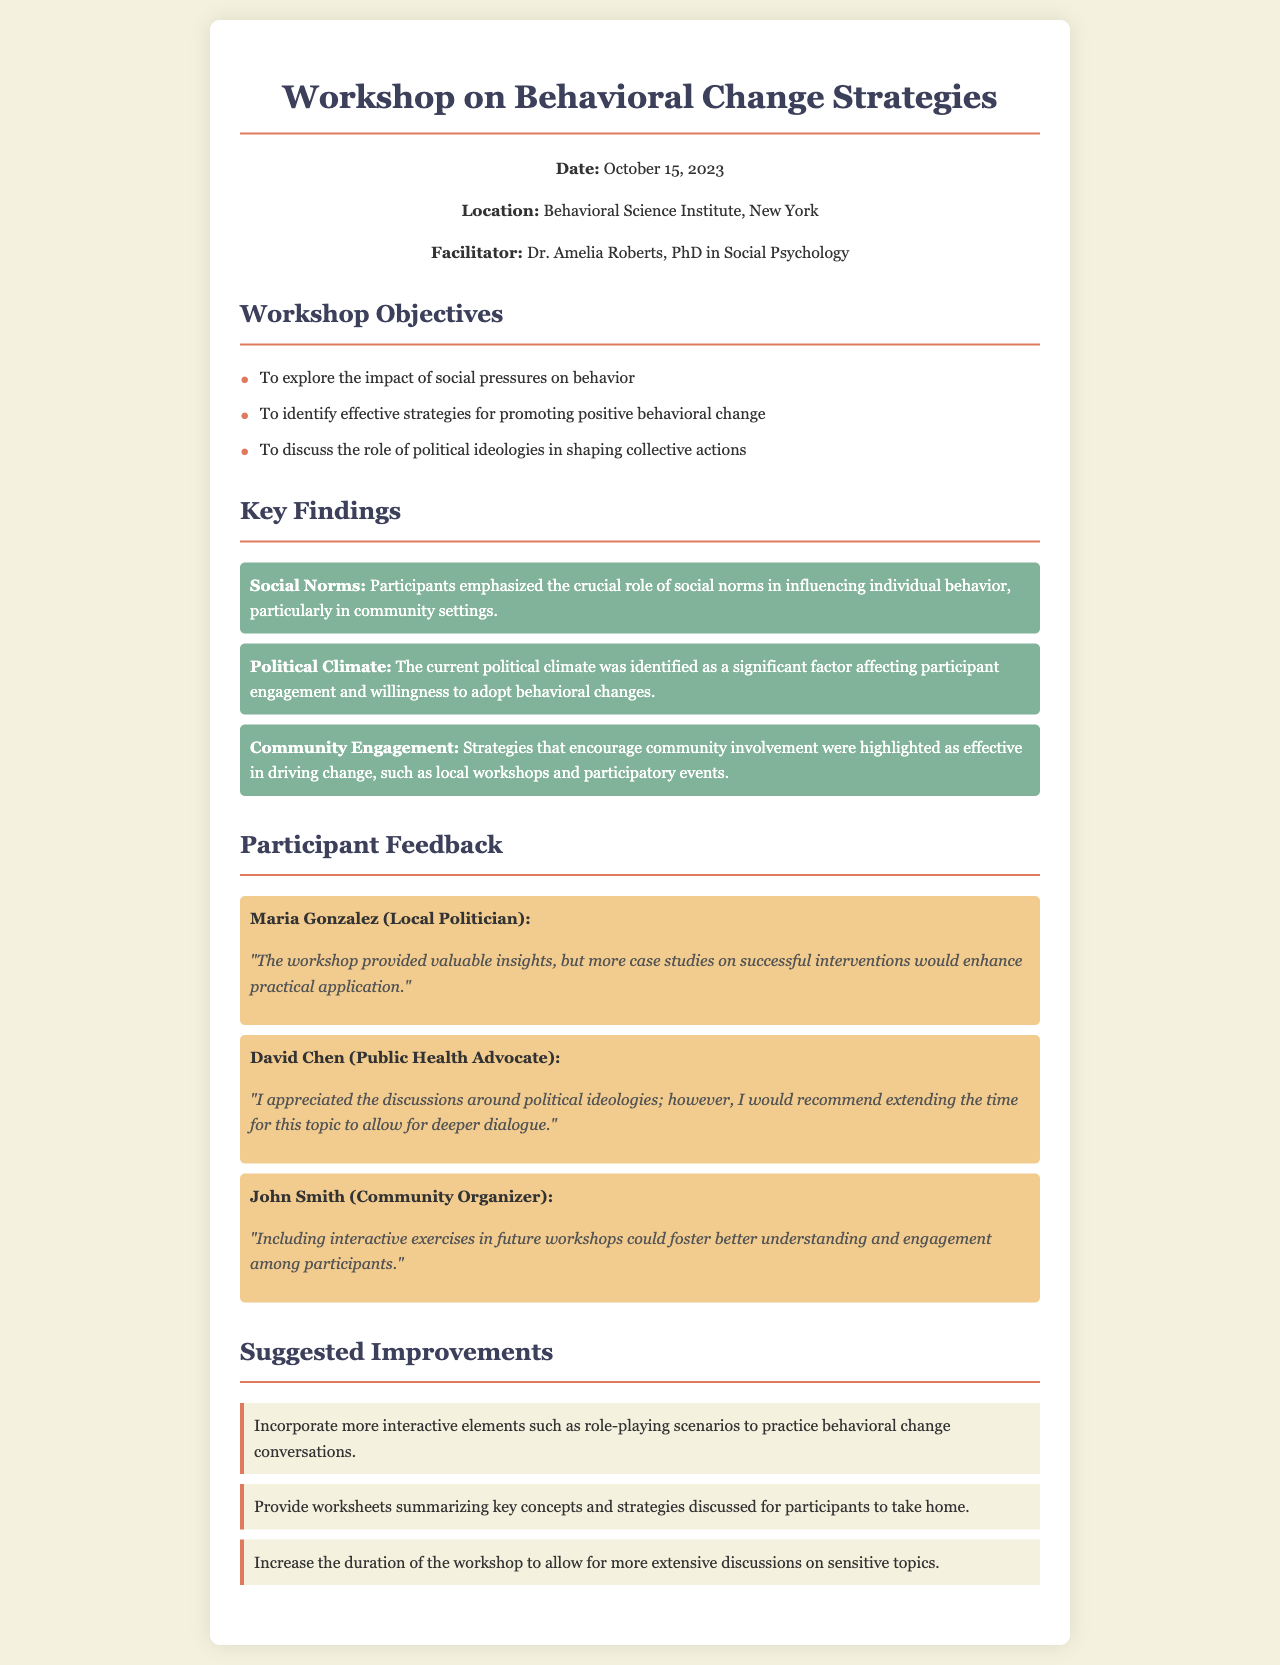What was the date of the workshop? The date of the workshop is explicitly mentioned in the document.
Answer: October 15, 2023 Who facilitated the workshop? The facilitator's name and qualification are provided in the document.
Answer: Dr. Amelia Roberts What is one of the workshop objectives? The objectives are listed in a bullet format, making it easy to identify.
Answer: To explore the impact of social pressures on behavior Which participant suggested including more case studies? The feedback section includes specific participant comments and names.
Answer: Maria Gonzalez What key finding suggests the influence of community involvement? The key findings summarize important points, one of which emphasizes community strategies.
Answer: Community Engagement What is a suggested improvement for future workshops? The suggestions are outlined at the end of the document, detailing improvements.
Answer: Incorporate more interactive elements What role did the political climate play according to participants? The document lists findings related to the political climate's impact on the workshop.
Answer: Significant factor affecting participant engagement How did participants react to the discussions on political ideologies? Feedback includes specific comments on the discussions from participants.
Answer: Need for deeper dialogue 